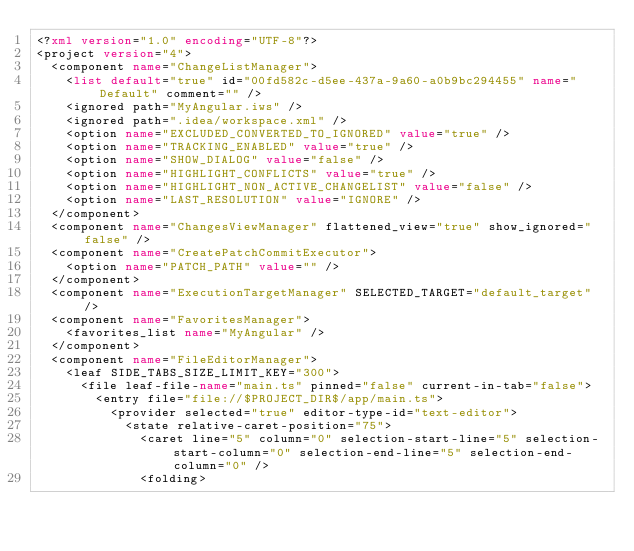<code> <loc_0><loc_0><loc_500><loc_500><_XML_><?xml version="1.0" encoding="UTF-8"?>
<project version="4">
  <component name="ChangeListManager">
    <list default="true" id="00fd582c-d5ee-437a-9a60-a0b9bc294455" name="Default" comment="" />
    <ignored path="MyAngular.iws" />
    <ignored path=".idea/workspace.xml" />
    <option name="EXCLUDED_CONVERTED_TO_IGNORED" value="true" />
    <option name="TRACKING_ENABLED" value="true" />
    <option name="SHOW_DIALOG" value="false" />
    <option name="HIGHLIGHT_CONFLICTS" value="true" />
    <option name="HIGHLIGHT_NON_ACTIVE_CHANGELIST" value="false" />
    <option name="LAST_RESOLUTION" value="IGNORE" />
  </component>
  <component name="ChangesViewManager" flattened_view="true" show_ignored="false" />
  <component name="CreatePatchCommitExecutor">
    <option name="PATCH_PATH" value="" />
  </component>
  <component name="ExecutionTargetManager" SELECTED_TARGET="default_target" />
  <component name="FavoritesManager">
    <favorites_list name="MyAngular" />
  </component>
  <component name="FileEditorManager">
    <leaf SIDE_TABS_SIZE_LIMIT_KEY="300">
      <file leaf-file-name="main.ts" pinned="false" current-in-tab="false">
        <entry file="file://$PROJECT_DIR$/app/main.ts">
          <provider selected="true" editor-type-id="text-editor">
            <state relative-caret-position="75">
              <caret line="5" column="0" selection-start-line="5" selection-start-column="0" selection-end-line="5" selection-end-column="0" />
              <folding></code> 